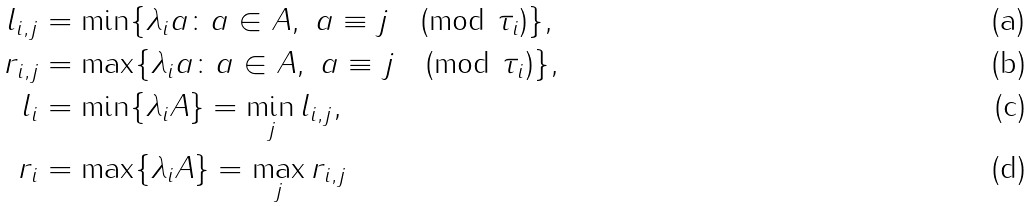<formula> <loc_0><loc_0><loc_500><loc_500>l _ { i , j } & = \min \{ \lambda _ { i } a \colon a \in A , \ a \equiv j \pmod { \tau _ { i } } \} , \\ r _ { i , j } & = \max \{ \lambda _ { i } a \colon a \in A , \ a \equiv j \pmod { \tau _ { i } } \} , \\ l _ { i } & = \min \{ \lambda _ { i } A \} = \min _ { j } l _ { i , j } , \\ r _ { i } & = \max \{ \lambda _ { i } A \} = \max _ { j } r _ { i , j }</formula> 